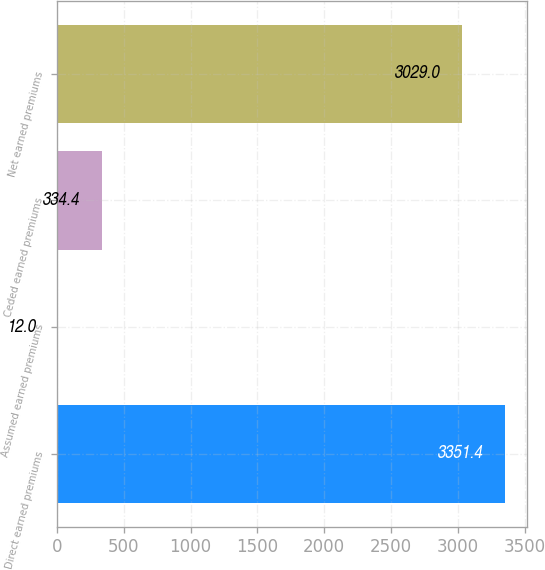Convert chart. <chart><loc_0><loc_0><loc_500><loc_500><bar_chart><fcel>Direct earned premiums<fcel>Assumed earned premiums<fcel>Ceded earned premiums<fcel>Net earned premiums<nl><fcel>3351.4<fcel>12<fcel>334.4<fcel>3029<nl></chart> 